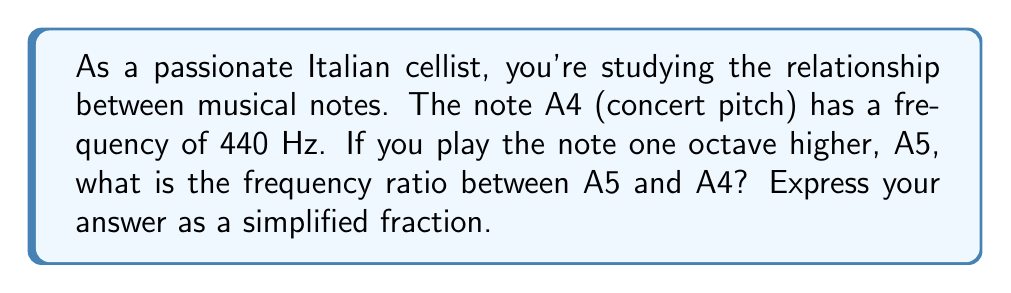Show me your answer to this math problem. To solve this problem, we need to understand the relationship between musical octaves and frequencies:

1. In Western music, an octave represents a doubling of frequency.

2. The frequency ratio between two notes an octave apart is always 2:1.

3. In this case, A5 is one octave higher than A4.

Therefore, we can set up the following equation:

$$\frac{f_{A5}}{f_{A4}} = 2$$

Where $f_{A5}$ is the frequency of A5 and $f_{A4}$ is the frequency of A4.

We know that $f_{A4} = 440$ Hz, so:

$$\frac{f_{A5}}{440} = 2$$

This ratio can be expressed as a fraction:

$$\frac{f_{A5}}{f_{A4}} = \frac{2}{1}$$

This fraction is already in its simplest form.
Answer: $\frac{2}{1}$ or 2:1 